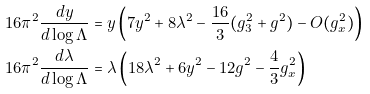Convert formula to latex. <formula><loc_0><loc_0><loc_500><loc_500>1 6 \pi ^ { 2 } \frac { d y } { d \log \Lambda } & = y \left ( 7 y ^ { 2 } + 8 \lambda ^ { 2 } - \frac { 1 6 } { 3 } ( g _ { 3 } ^ { 2 } + g ^ { 2 } ) - O ( g _ { x } ^ { 2 } ) \right ) \\ 1 6 \pi ^ { 2 } \frac { d \lambda } { d \log \Lambda } & = \lambda \left ( 1 8 \lambda ^ { 2 } + 6 y ^ { 2 } - 1 2 g ^ { 2 } - \frac { 4 } { 3 } g _ { x } ^ { 2 } \right )</formula> 